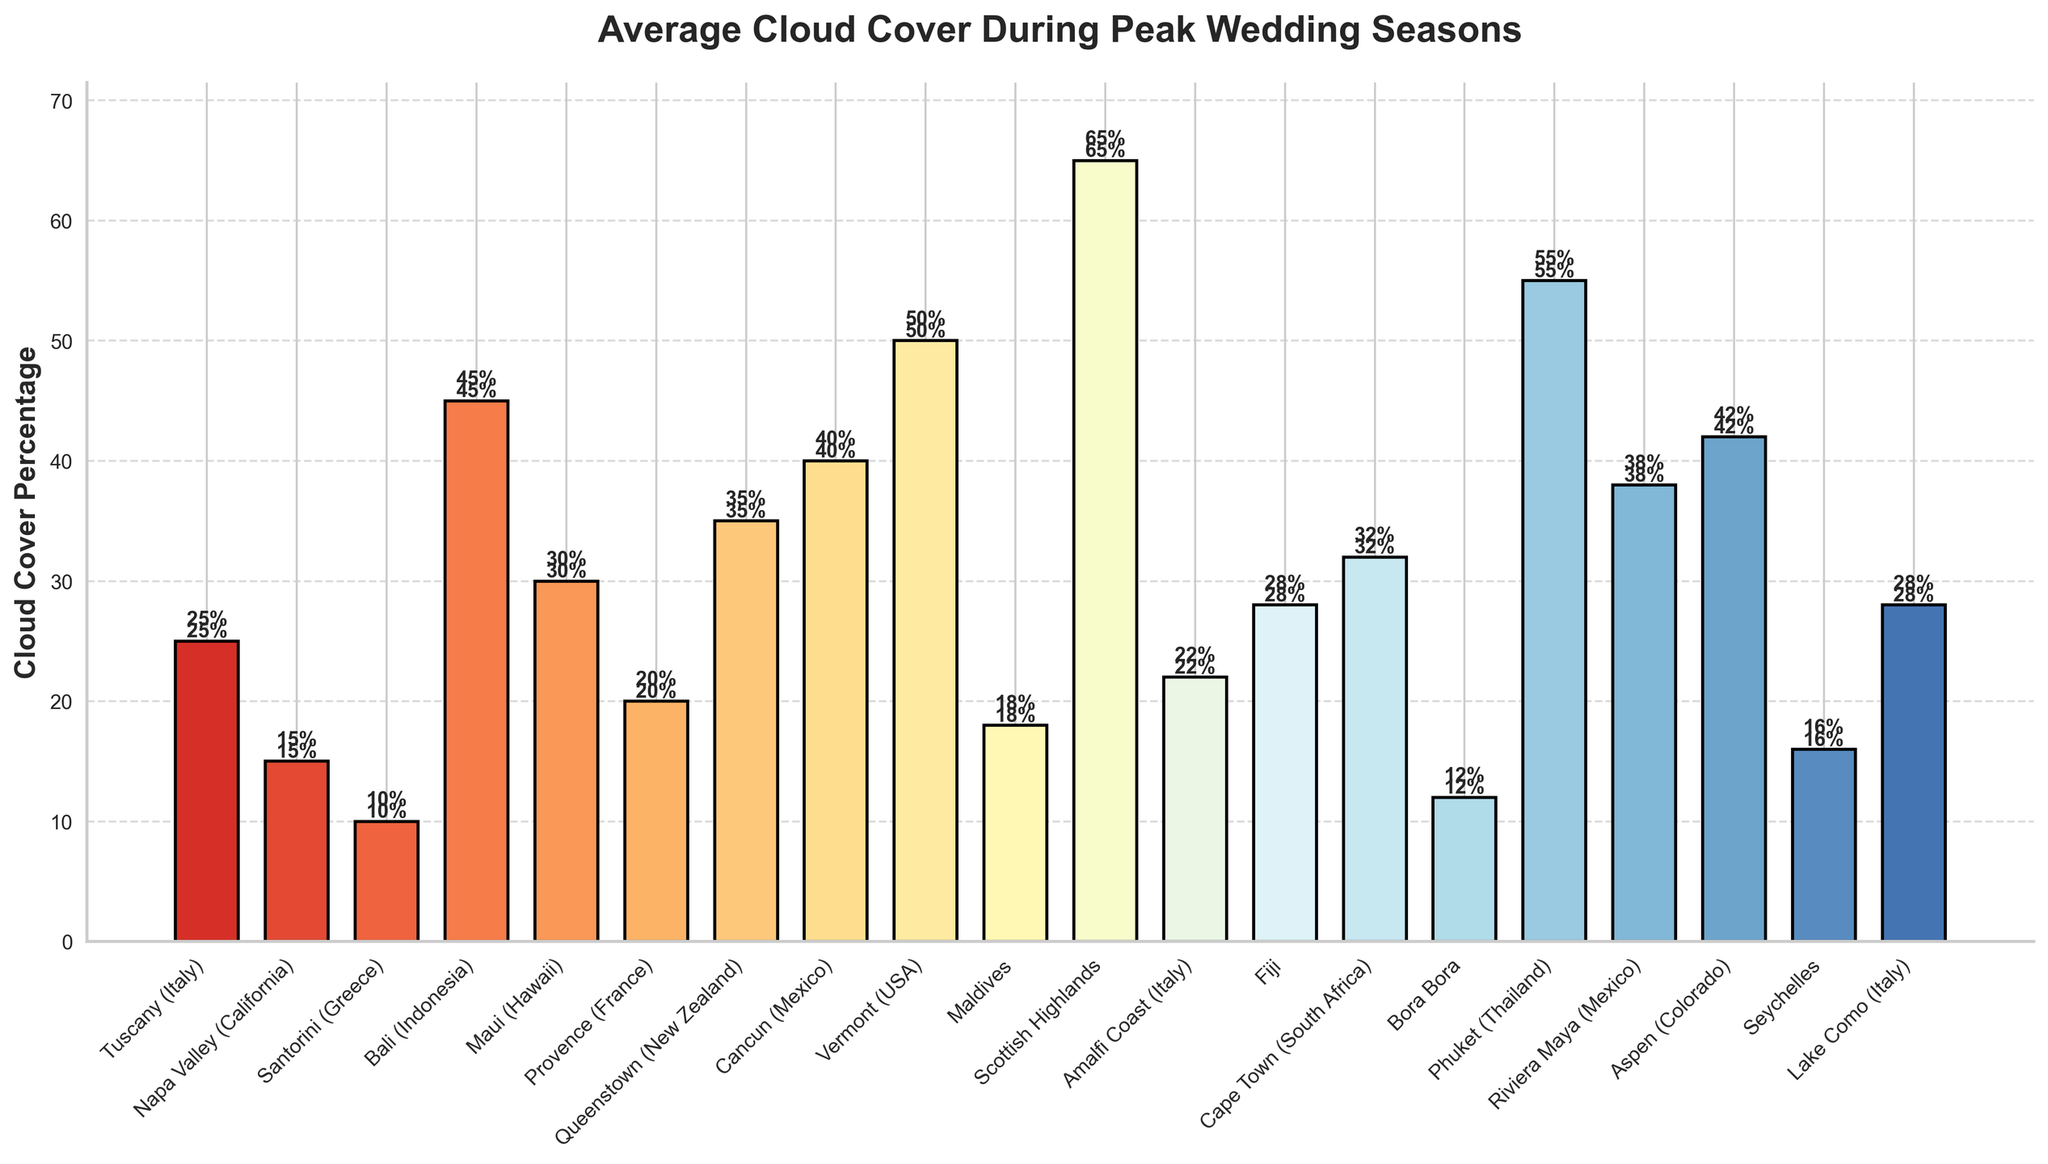Which region has the highest average cloud cover during peak wedding season? The bar chart visually represents the cloud cover percentages for each region. The tallest bar represents the Scottish Highlands with a percentage of 65%.
Answer: Scottish Highlands Which regions have more than 40% average cloud cover? To find this, locate the bars that exceed the 40% mark. These regions are Vermont, Phuket, and Scottish Highlands.
Answer: Vermont, Phuket, Scottish Highlands Which regions have less average cloud cover than Bali (Indonesia)? Bali's bar is at 45%. All bars shorter than Bali’s represent regions with less cloud cover, which include Tuscany, Napa Valley, Santorini, Provence, Amalfi Coast, Maldives, Seychelles, Bora Bora, and Lake Como.
Answer: Tuscany, Napa Valley, Santorini, Provence, Amalfi Coast, Maldives, Seychelles, Bora Bora, Lake Como What is the average cloud cover for regions in Italy? Add the cloud cover percentages for Tuscany (25%), Amalfi Coast (22%), and Lake Como (28%). Then, divide by 3. So, the calculation is (25 + 22 + 28) / 3 = 75 / 3.
Answer: 25% Between Fiji and Cape Town, which region has higher cloud cover, and by how much? Fiji's bar is at 28%, and Cape Town's is at 32%. Subtract 28 from 32 to find the difference.
Answer: Cape Town, by 4% Which region has the lowest average cloud cover during peak wedding season? The shortest bar indicates the lowest cloud cover, which is for Santorini with a percentage of 10%.
Answer: Santorini Arrange Bali, Cancun, and Aspen in descending order of cloud cover percentage. Check the heights of the bars for Bali (45%), Cancun (40%), and Aspen (42%). Sort them: Bali (45%), Aspen (42%), Cancun (40%).
Answer: Bali, Aspen, Cancun What is the total cloud cover percentage for the regions in Mexico? Add the cloud cover percentages for Cancun (40%) and Riviera Maya (38%). So, the calculation is 40 + 38.
Answer: 78% What is the difference in cloud cover between the region with the highest and the region with the lowest cloud cover? The highest cloud cover is in the Scottish Highlands (65%), and the lowest is in Santorini (10%). The difference is 65 - 10.
Answer: 55% How many regions have average cloud cover percentages between 20% and 40%? Count the number of bars that fall between the 20% and 40% marks. These include Tuscany, Maui, Provence, Amalfi Coast, Fiji, Maldives, Bora Bora, Riviera Maya, and Seychelles. So there are 9 regions.
Answer: 9 